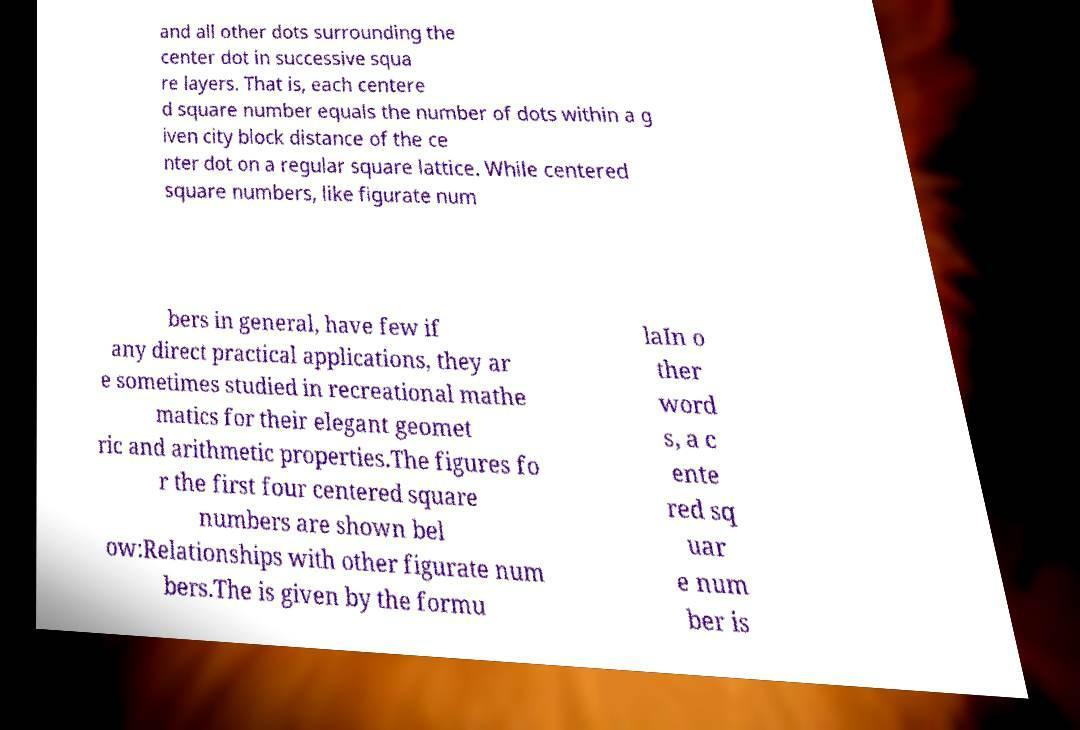Please read and relay the text visible in this image. What does it say? and all other dots surrounding the center dot in successive squa re layers. That is, each centere d square number equals the number of dots within a g iven city block distance of the ce nter dot on a regular square lattice. While centered square numbers, like figurate num bers in general, have few if any direct practical applications, they ar e sometimes studied in recreational mathe matics for their elegant geomet ric and arithmetic properties.The figures fo r the first four centered square numbers are shown bel ow:Relationships with other figurate num bers.The is given by the formu laIn o ther word s, a c ente red sq uar e num ber is 